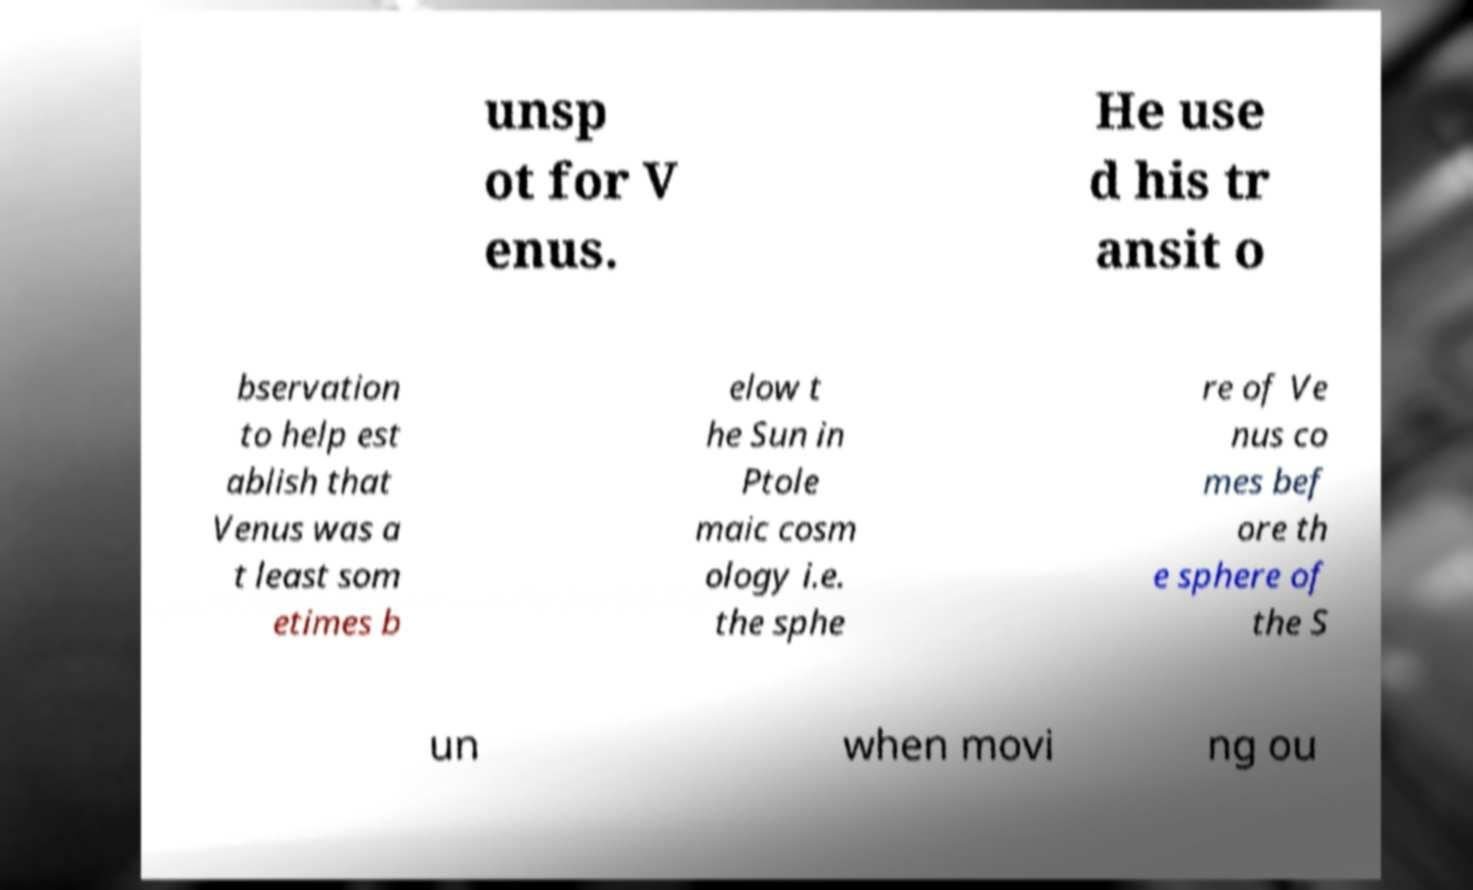Can you read and provide the text displayed in the image?This photo seems to have some interesting text. Can you extract and type it out for me? unsp ot for V enus. He use d his tr ansit o bservation to help est ablish that Venus was a t least som etimes b elow t he Sun in Ptole maic cosm ology i.e. the sphe re of Ve nus co mes bef ore th e sphere of the S un when movi ng ou 